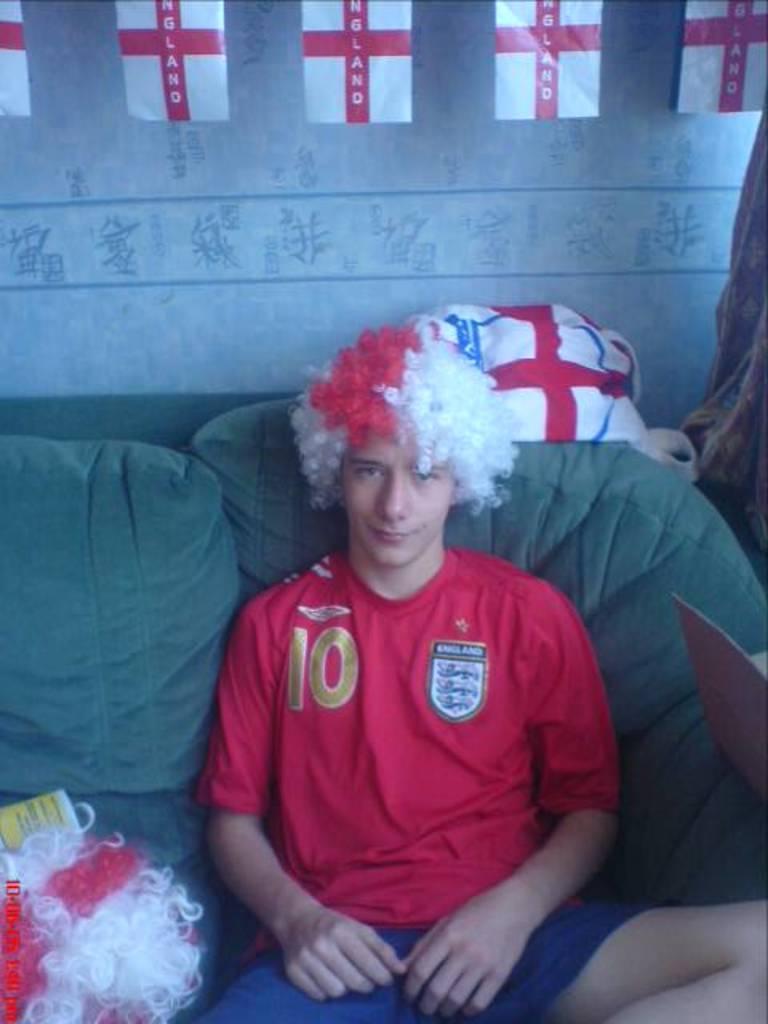How would you summarize this image in a sentence or two? In this image I can see a man is sitting. I can see he is wearing red t shirt and blue shorts. I can also see few wigs and few white colour flags. I can also see a white colour cloth over here. 